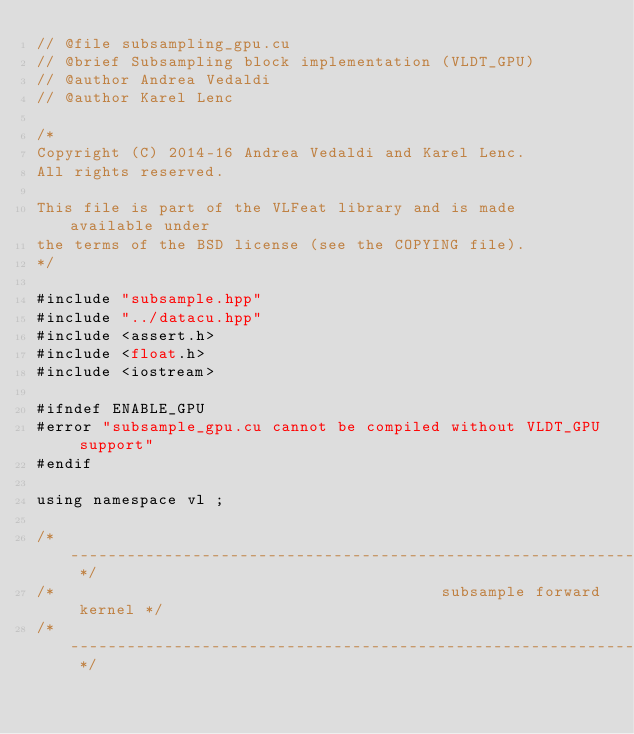<code> <loc_0><loc_0><loc_500><loc_500><_Cuda_>// @file subsampling_gpu.cu
// @brief Subsampling block implementation (VLDT_GPU)
// @author Andrea Vedaldi
// @author Karel Lenc

/*
Copyright (C) 2014-16 Andrea Vedaldi and Karel Lenc.
All rights reserved.

This file is part of the VLFeat library and is made available under
the terms of the BSD license (see the COPYING file).
*/

#include "subsample.hpp"
#include "../datacu.hpp"
#include <assert.h>
#include <float.h>
#include <iostream>

#ifndef ENABLE_GPU
#error "subsample_gpu.cu cannot be compiled without VLDT_GPU support"
#endif

using namespace vl ;

/* ---------------------------------------------------------------- */
/*                                         subsample forward kernel */
/* ---------------------------------------------------------------- */
</code> 